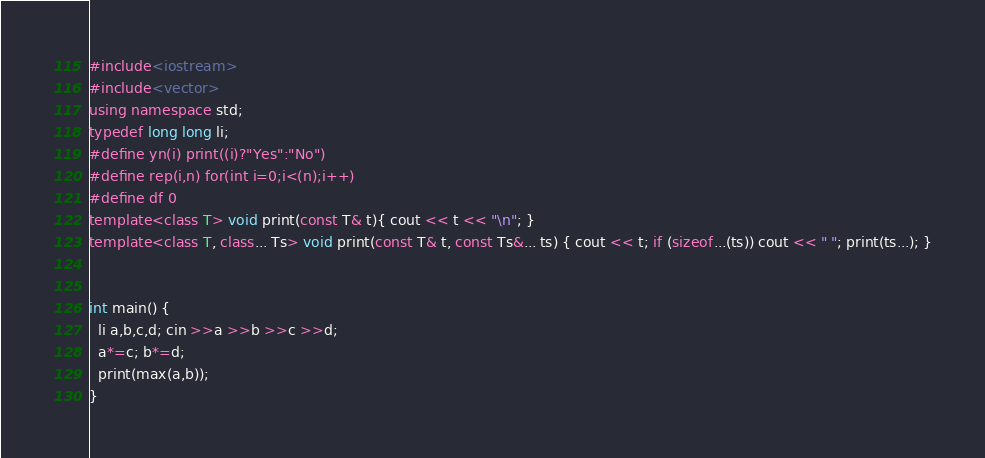<code> <loc_0><loc_0><loc_500><loc_500><_C++_>#include<iostream>
#include<vector>
using namespace std;
typedef long long li;
#define yn(i) print((i)?"Yes":"No")
#define rep(i,n) for(int i=0;i<(n);i++)
#define df 0
template<class T> void print(const T& t){ cout << t << "\n"; }
template<class T, class... Ts> void print(const T& t, const Ts&... ts) { cout << t; if (sizeof...(ts)) cout << " "; print(ts...); }


int main() {
  li a,b,c,d; cin >>a >>b >>c >>d;
  a*=c; b*=d;
  print(max(a,b));
}
</code> 